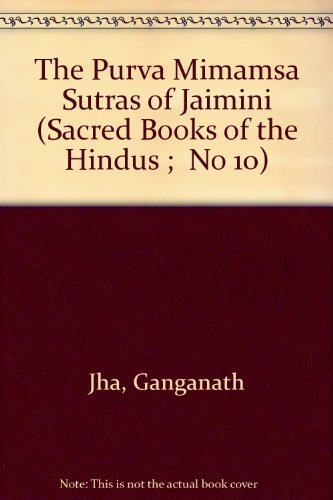Can you tell me more about the school of thought this book represents? Certainly. This book represents Mimamsa, which is one of the six orthodox schools of Hindu philosophy. It primarily deals with the interpretation of Vedic rituals and ethics, emphasizing the performance of duties and the significance of sacred rituals in achieving dharma (moral order). 